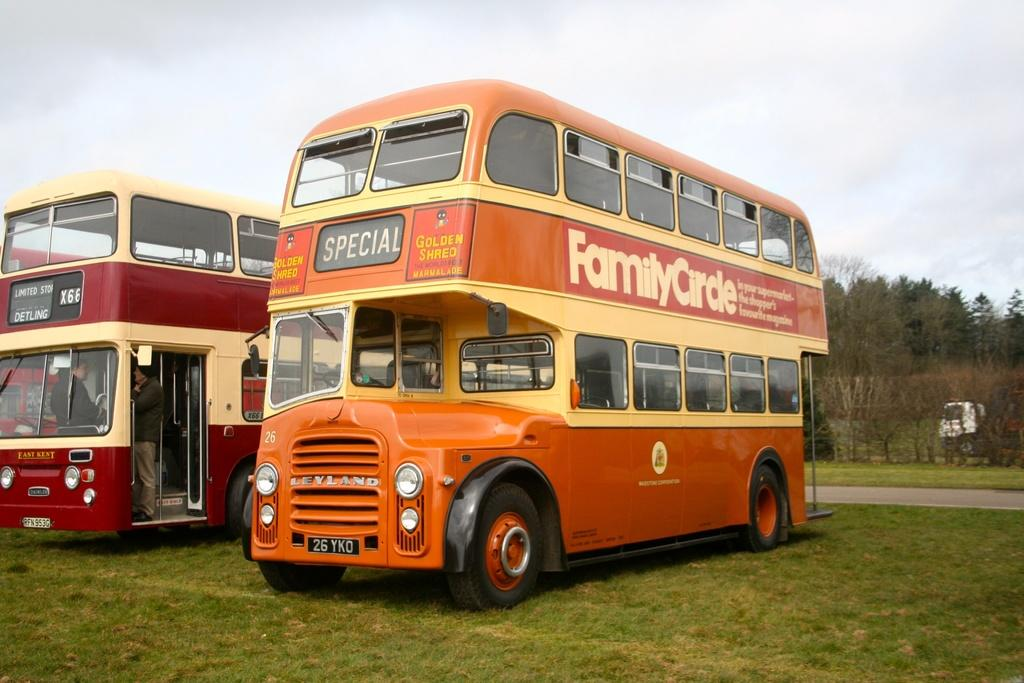<image>
Render a clear and concise summary of the photo. An orange double decker bus says Family Circle on the side. 